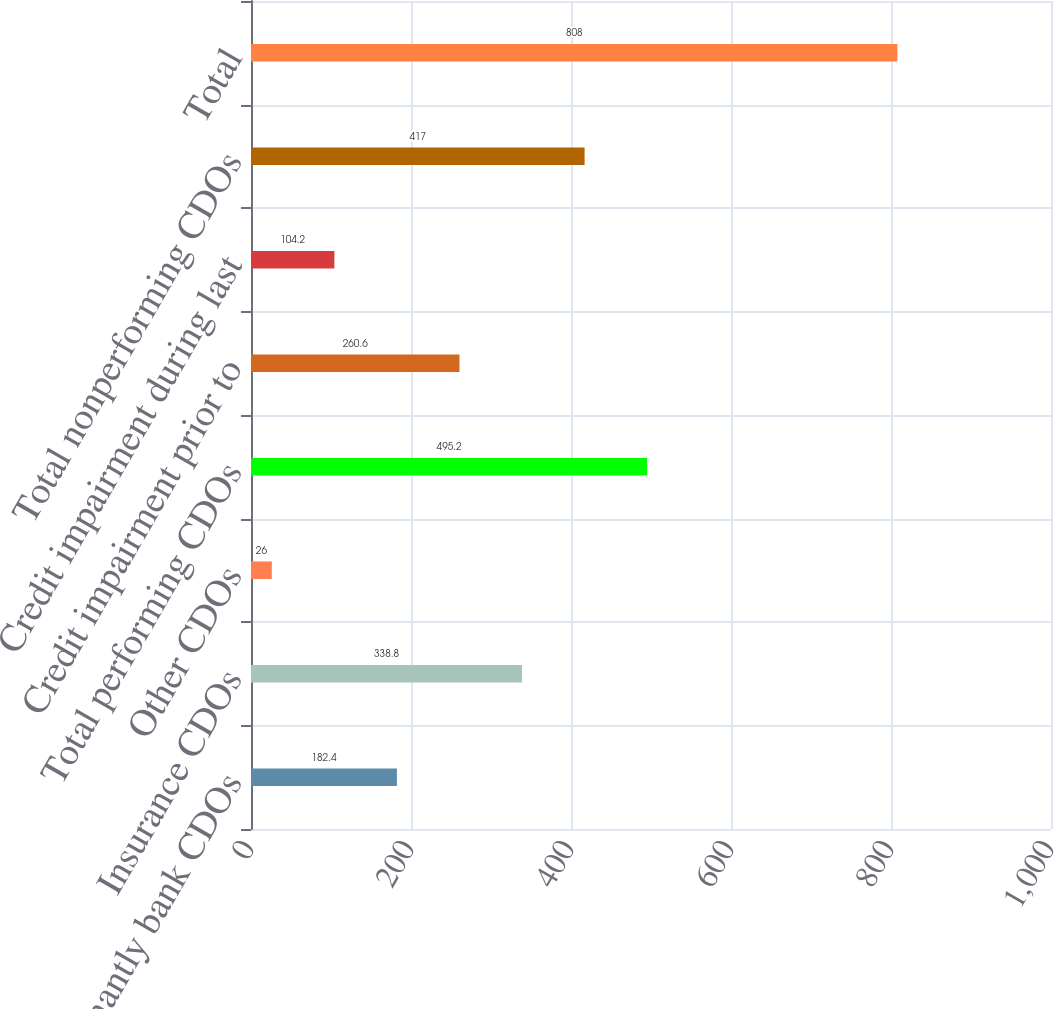Convert chart to OTSL. <chart><loc_0><loc_0><loc_500><loc_500><bar_chart><fcel>Predominantly bank CDOs<fcel>Insurance CDOs<fcel>Other CDOs<fcel>Total performing CDOs<fcel>Credit impairment prior to<fcel>Credit impairment during last<fcel>Total nonperforming CDOs<fcel>Total<nl><fcel>182.4<fcel>338.8<fcel>26<fcel>495.2<fcel>260.6<fcel>104.2<fcel>417<fcel>808<nl></chart> 